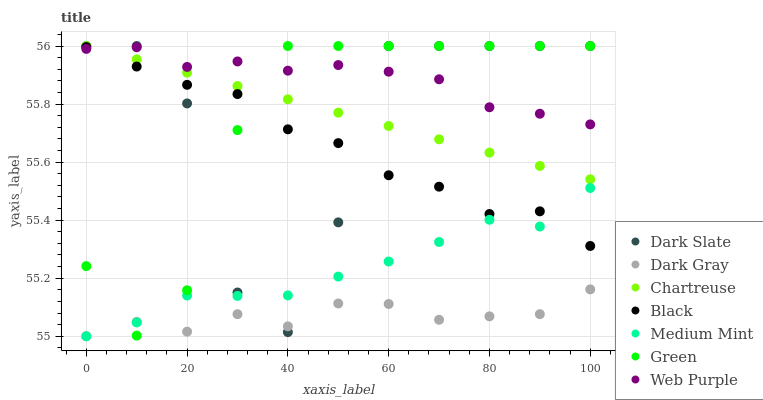Does Dark Gray have the minimum area under the curve?
Answer yes or no. Yes. Does Web Purple have the maximum area under the curve?
Answer yes or no. Yes. Does Web Purple have the minimum area under the curve?
Answer yes or no. No. Does Dark Gray have the maximum area under the curve?
Answer yes or no. No. Is Chartreuse the smoothest?
Answer yes or no. Yes. Is Dark Slate the roughest?
Answer yes or no. Yes. Is Web Purple the smoothest?
Answer yes or no. No. Is Web Purple the roughest?
Answer yes or no. No. Does Medium Mint have the lowest value?
Answer yes or no. Yes. Does Web Purple have the lowest value?
Answer yes or no. No. Does Green have the highest value?
Answer yes or no. Yes. Does Web Purple have the highest value?
Answer yes or no. No. Is Medium Mint less than Web Purple?
Answer yes or no. Yes. Is Web Purple greater than Medium Mint?
Answer yes or no. Yes. Does Green intersect Dark Slate?
Answer yes or no. Yes. Is Green less than Dark Slate?
Answer yes or no. No. Is Green greater than Dark Slate?
Answer yes or no. No. Does Medium Mint intersect Web Purple?
Answer yes or no. No. 